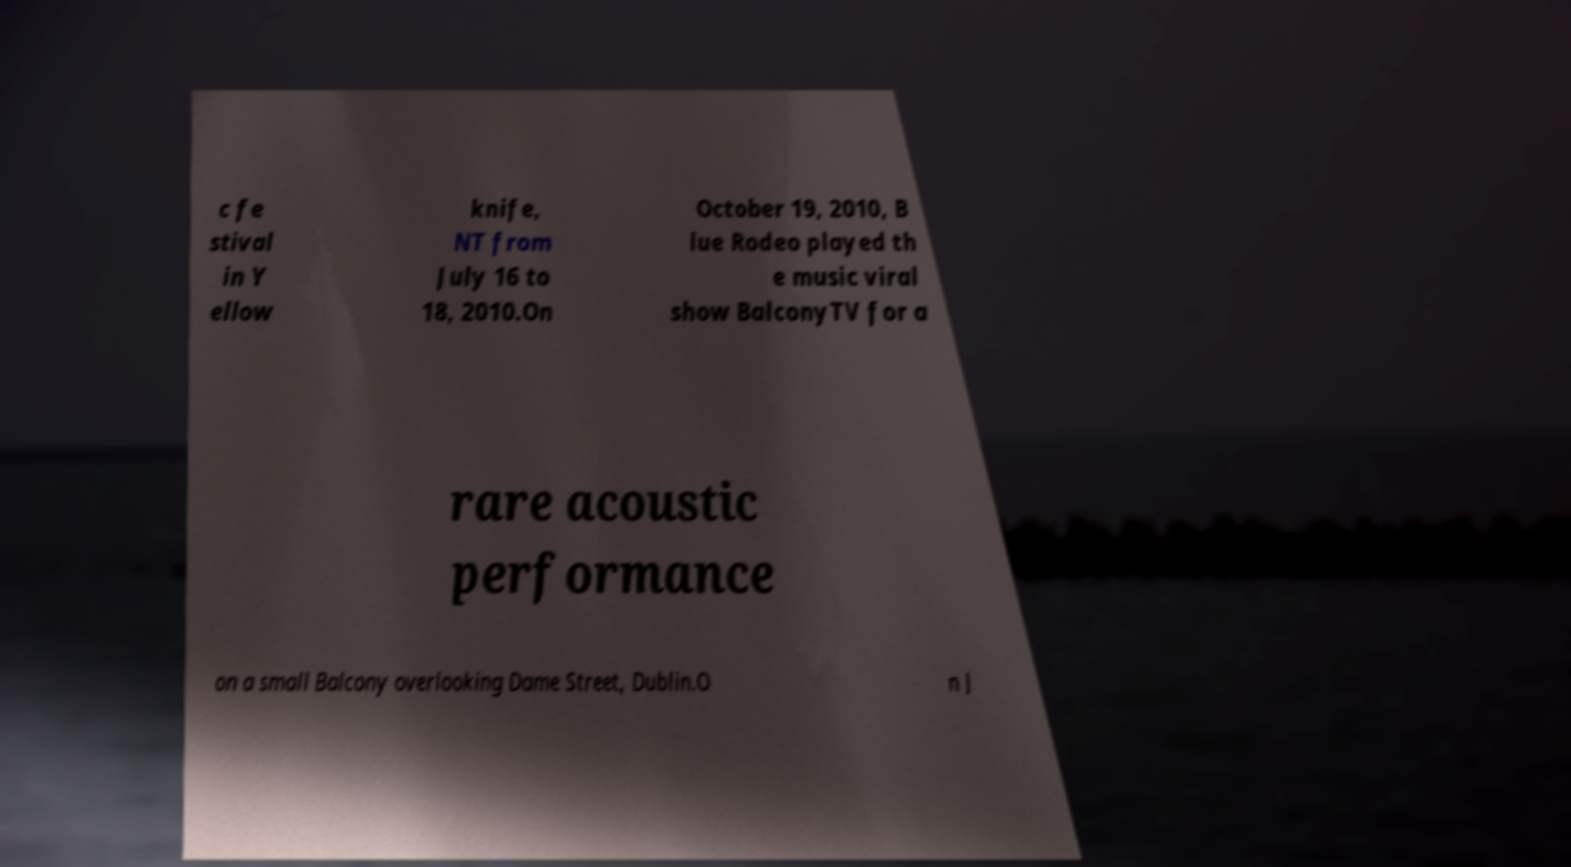Could you extract and type out the text from this image? c fe stival in Y ellow knife, NT from July 16 to 18, 2010.On October 19, 2010, B lue Rodeo played th e music viral show BalconyTV for a rare acoustic performance on a small Balcony overlooking Dame Street, Dublin.O n J 